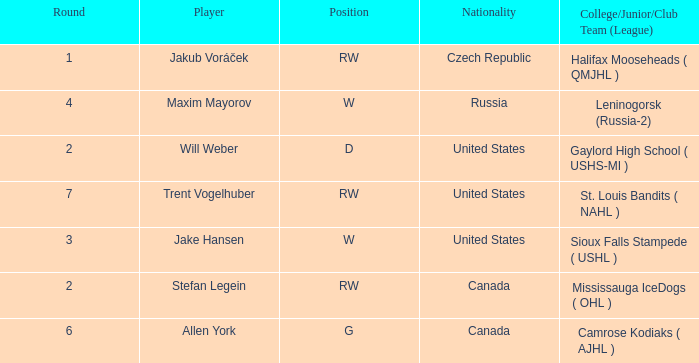What nationality is the draft pick with w position from leninogorsk (russia-2)? Russia. 